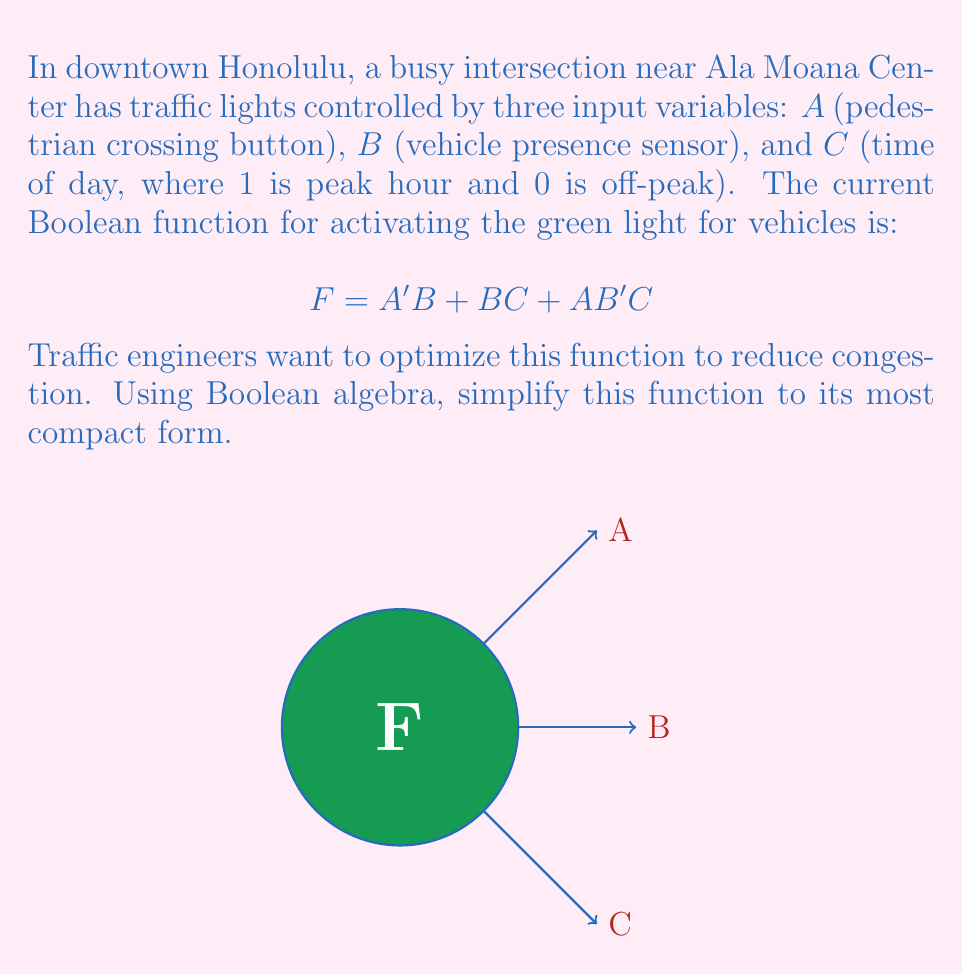Teach me how to tackle this problem. Let's simplify the function $F = A'B + BC + AB'C$ step by step using Boolean algebra:

1) First, let's apply the distributive property to the term $BC$:
   $$F = A'B + BC + AB'C$$
   $$F = A'B + ABC + A'BC + AB'C$$

2) Now we have four terms. Let's group similar terms:
   $$F = A'B + ABC + A'BC + AB'C$$
   $$F = B(A' + C) + AC(B + B')$$

3) Simplify $B + B'$ in the second term:
   $$F = B(A' + C) + AC(1)$$
   $$F = B(A' + C) + AC$$

4) Distribute $B$ in the first term:
   $$F = BA' + BC + AC$$

5) Now, let's apply the absorption law to $BC + AC$:
   $$F = BA' + C(B + A)$$

6) This is the most simplified form of the function.
Answer: $F = BA' + C(B + A)$ 